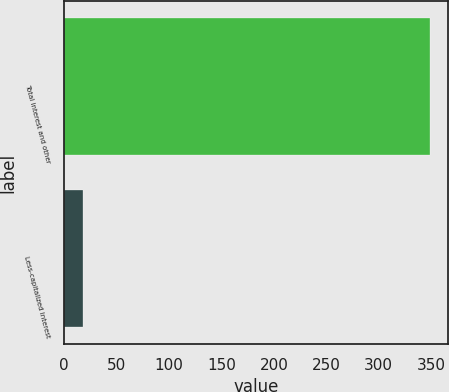<chart> <loc_0><loc_0><loc_500><loc_500><bar_chart><fcel>Total interest and other<fcel>Less-capitalized interest<nl><fcel>349<fcel>18<nl></chart> 